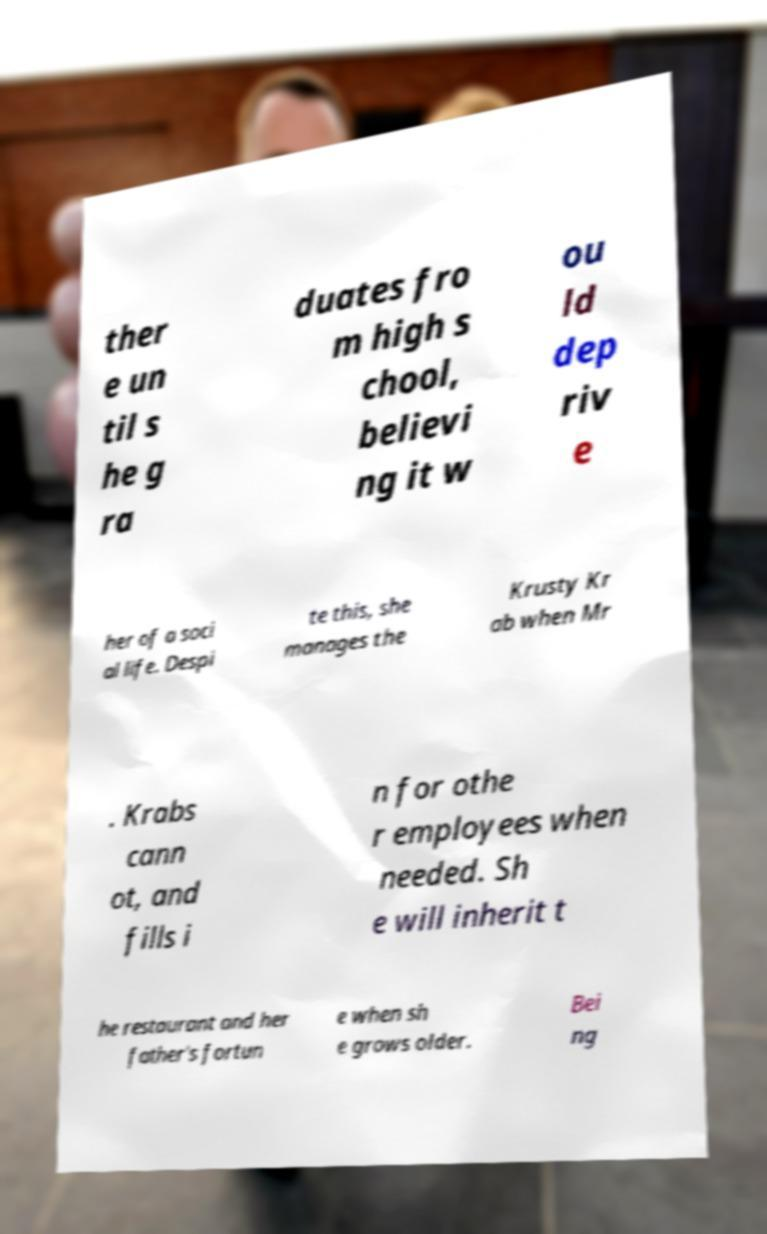I need the written content from this picture converted into text. Can you do that? ther e un til s he g ra duates fro m high s chool, believi ng it w ou ld dep riv e her of a soci al life. Despi te this, she manages the Krusty Kr ab when Mr . Krabs cann ot, and fills i n for othe r employees when needed. Sh e will inherit t he restaurant and her father's fortun e when sh e grows older. Bei ng 